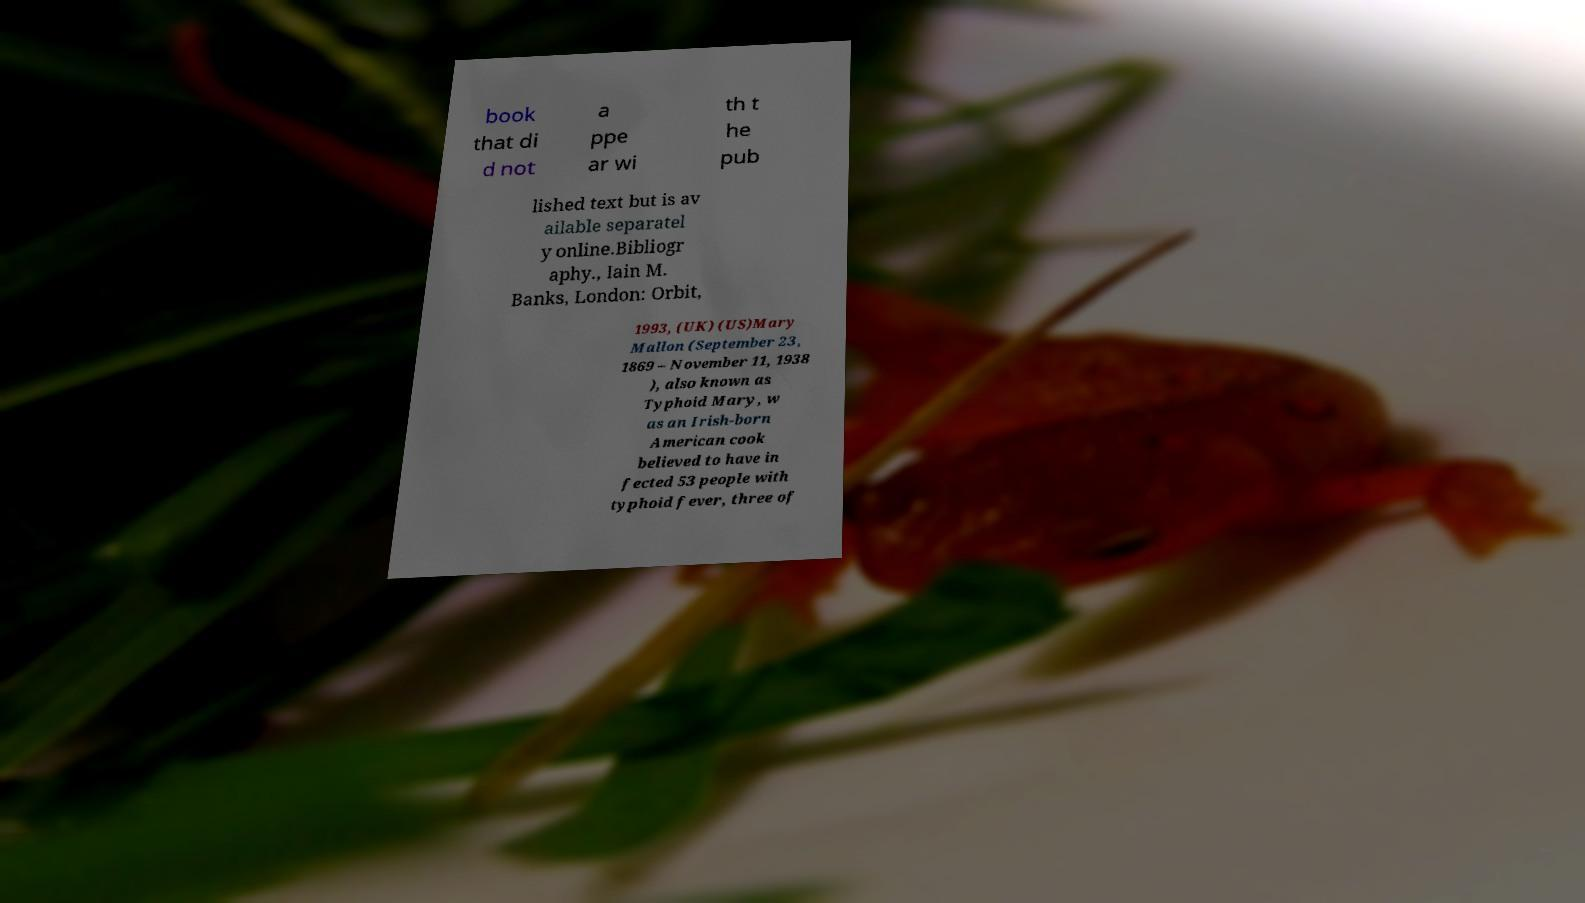Could you extract and type out the text from this image? book that di d not a ppe ar wi th t he pub lished text but is av ailable separatel y online.Bibliogr aphy., Iain M. Banks, London: Orbit, 1993, (UK) (US)Mary Mallon (September 23, 1869 – November 11, 1938 ), also known as Typhoid Mary, w as an Irish-born American cook believed to have in fected 53 people with typhoid fever, three of 